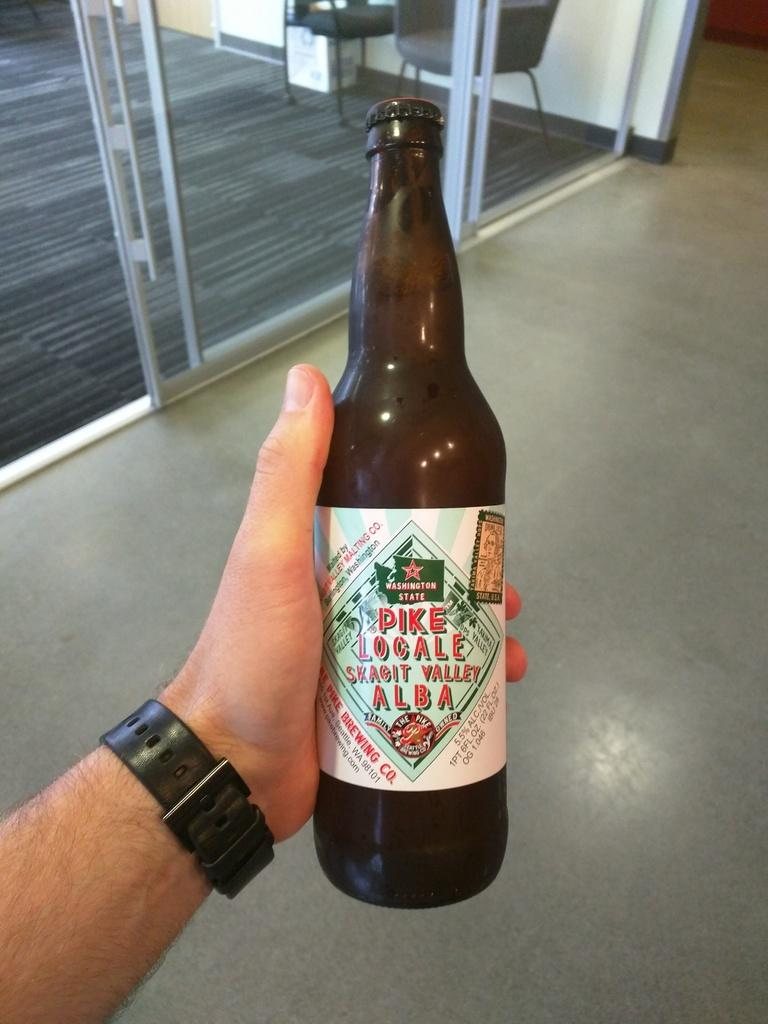<image>
Summarize the visual content of the image. A bottle of beer from a Washington State brewery. 